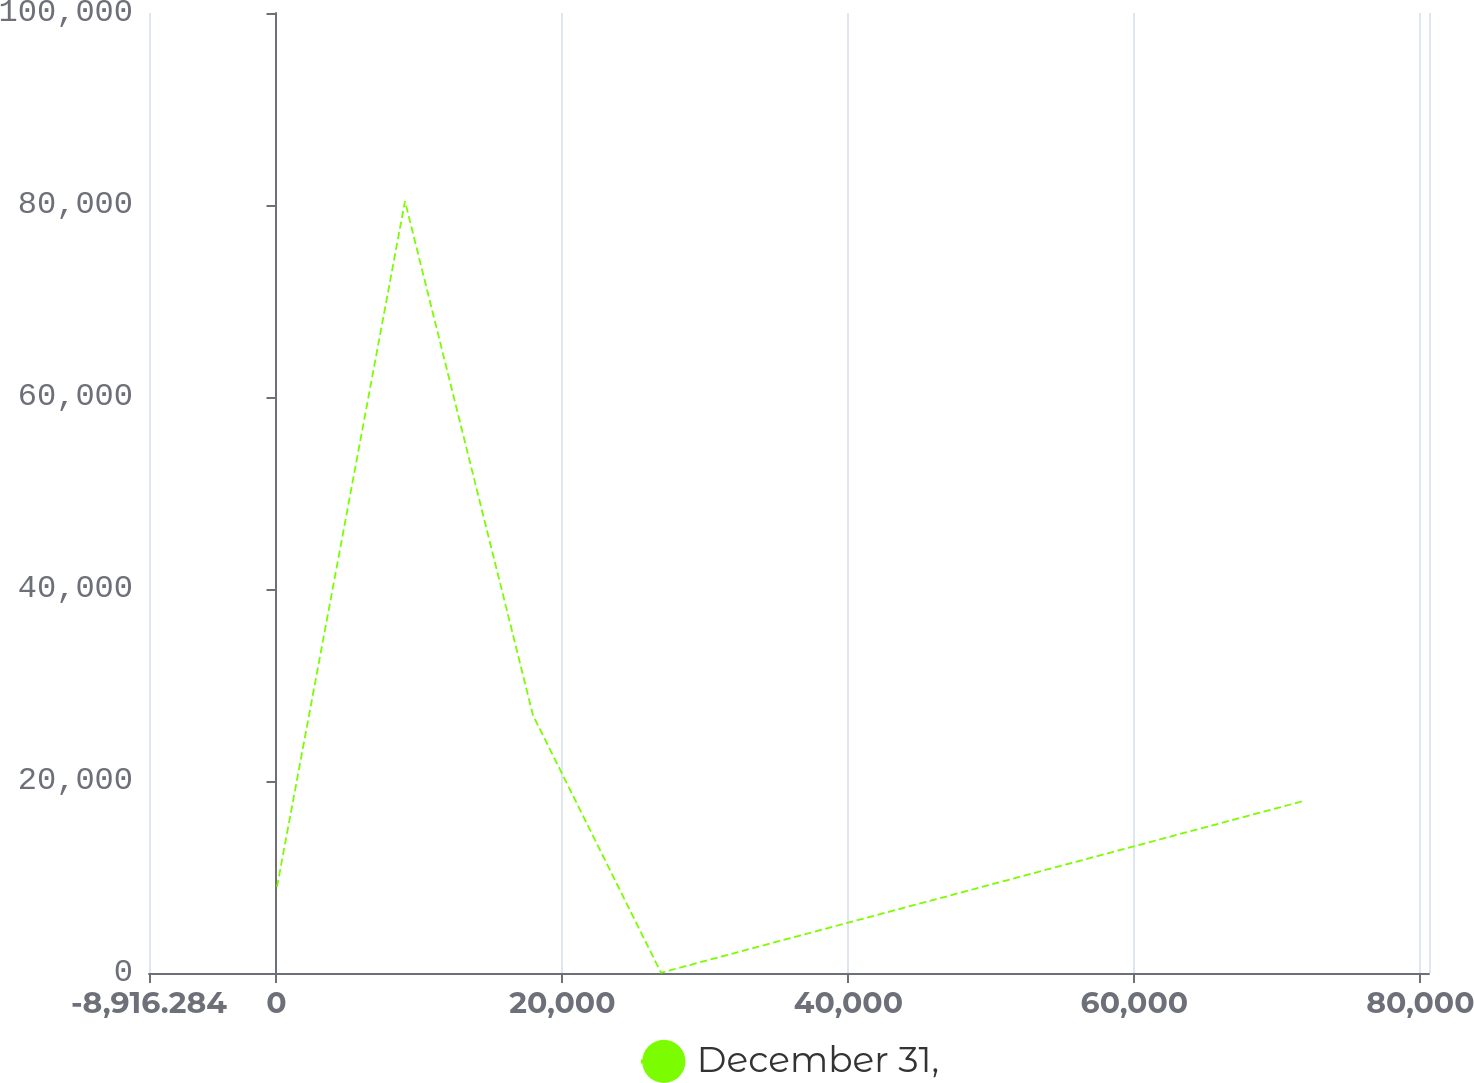<chart> <loc_0><loc_0><loc_500><loc_500><line_chart><ecel><fcel>December 31,<nl><fcel>35.76<fcel>8970.53<nl><fcel>8987.8<fcel>80391.1<nl><fcel>17939.8<fcel>26848.8<nl><fcel>26891.9<fcel>31.37<nl><fcel>71812.8<fcel>17909.7<nl><fcel>89556.2<fcel>89423<nl></chart> 